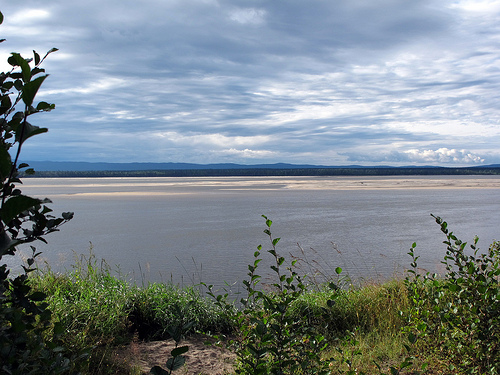<image>
Can you confirm if the river is in front of the grass? Yes. The river is positioned in front of the grass, appearing closer to the camera viewpoint. 